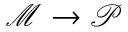Convert formula to latex. <formula><loc_0><loc_0><loc_500><loc_500>\mathcal { M } \rightarrow \mathcal { P }</formula> 